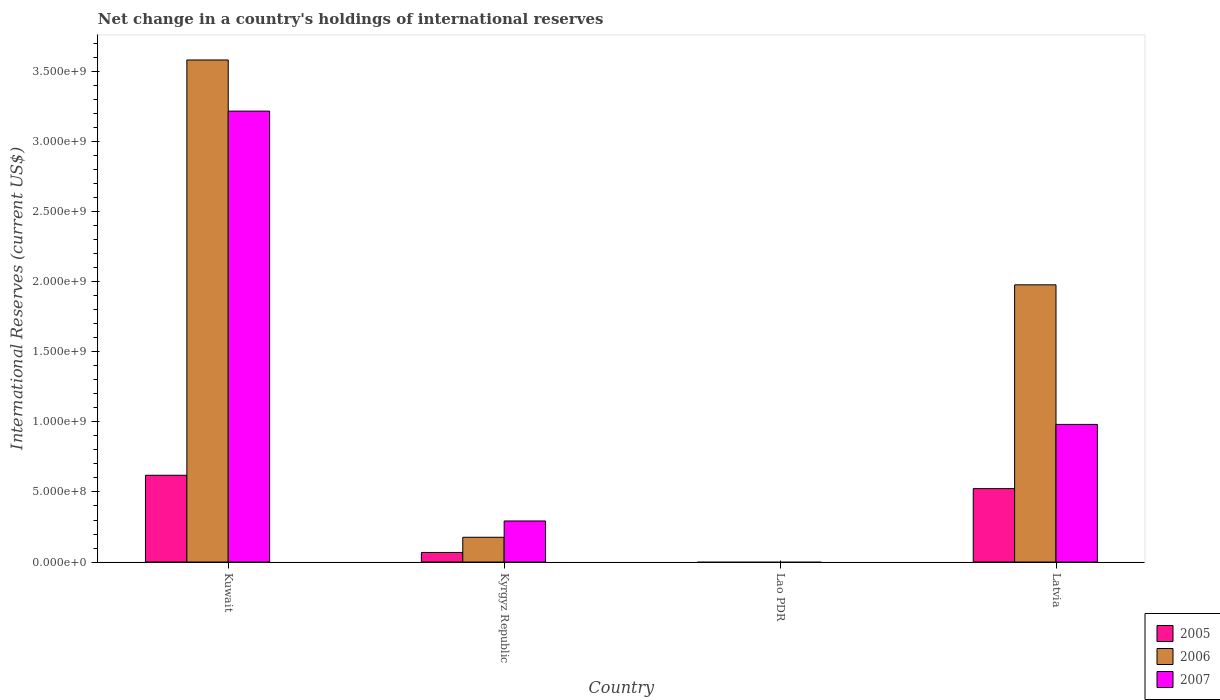How many different coloured bars are there?
Offer a terse response. 3. How many bars are there on the 1st tick from the left?
Your response must be concise. 3. How many bars are there on the 2nd tick from the right?
Your answer should be very brief. 0. What is the label of the 2nd group of bars from the left?
Provide a short and direct response. Kyrgyz Republic. What is the international reserves in 2007 in Kyrgyz Republic?
Your answer should be compact. 2.93e+08. Across all countries, what is the maximum international reserves in 2007?
Your answer should be compact. 3.22e+09. Across all countries, what is the minimum international reserves in 2006?
Provide a short and direct response. 0. In which country was the international reserves in 2006 maximum?
Offer a terse response. Kuwait. What is the total international reserves in 2007 in the graph?
Keep it short and to the point. 4.49e+09. What is the difference between the international reserves in 2007 in Kuwait and that in Kyrgyz Republic?
Provide a succinct answer. 2.93e+09. What is the difference between the international reserves in 2007 in Kyrgyz Republic and the international reserves in 2006 in Lao PDR?
Keep it short and to the point. 2.93e+08. What is the average international reserves in 2005 per country?
Your answer should be compact. 3.03e+08. What is the difference between the international reserves of/in 2006 and international reserves of/in 2007 in Kyrgyz Republic?
Give a very brief answer. -1.16e+08. What is the ratio of the international reserves in 2007 in Kuwait to that in Kyrgyz Republic?
Your answer should be very brief. 10.98. Is the international reserves in 2007 in Kuwait less than that in Latvia?
Your answer should be compact. No. What is the difference between the highest and the second highest international reserves in 2007?
Give a very brief answer. 2.24e+09. What is the difference between the highest and the lowest international reserves in 2007?
Offer a very short reply. 3.22e+09. In how many countries, is the international reserves in 2005 greater than the average international reserves in 2005 taken over all countries?
Offer a very short reply. 2. How many countries are there in the graph?
Provide a succinct answer. 4. What is the difference between two consecutive major ticks on the Y-axis?
Offer a terse response. 5.00e+08. Are the values on the major ticks of Y-axis written in scientific E-notation?
Your answer should be very brief. Yes. Does the graph contain any zero values?
Make the answer very short. Yes. Does the graph contain grids?
Your answer should be very brief. No. What is the title of the graph?
Keep it short and to the point. Net change in a country's holdings of international reserves. Does "1973" appear as one of the legend labels in the graph?
Provide a succinct answer. No. What is the label or title of the X-axis?
Provide a short and direct response. Country. What is the label or title of the Y-axis?
Offer a terse response. International Reserves (current US$). What is the International Reserves (current US$) of 2005 in Kuwait?
Ensure brevity in your answer.  6.19e+08. What is the International Reserves (current US$) of 2006 in Kuwait?
Offer a terse response. 3.58e+09. What is the International Reserves (current US$) of 2007 in Kuwait?
Offer a very short reply. 3.22e+09. What is the International Reserves (current US$) in 2005 in Kyrgyz Republic?
Give a very brief answer. 6.84e+07. What is the International Reserves (current US$) of 2006 in Kyrgyz Republic?
Keep it short and to the point. 1.77e+08. What is the International Reserves (current US$) in 2007 in Kyrgyz Republic?
Offer a terse response. 2.93e+08. What is the International Reserves (current US$) in 2007 in Lao PDR?
Your answer should be very brief. 0. What is the International Reserves (current US$) of 2005 in Latvia?
Your answer should be compact. 5.24e+08. What is the International Reserves (current US$) in 2006 in Latvia?
Ensure brevity in your answer.  1.98e+09. What is the International Reserves (current US$) of 2007 in Latvia?
Provide a succinct answer. 9.82e+08. Across all countries, what is the maximum International Reserves (current US$) in 2005?
Offer a very short reply. 6.19e+08. Across all countries, what is the maximum International Reserves (current US$) of 2006?
Ensure brevity in your answer.  3.58e+09. Across all countries, what is the maximum International Reserves (current US$) of 2007?
Offer a terse response. 3.22e+09. Across all countries, what is the minimum International Reserves (current US$) of 2005?
Make the answer very short. 0. Across all countries, what is the minimum International Reserves (current US$) in 2007?
Give a very brief answer. 0. What is the total International Reserves (current US$) of 2005 in the graph?
Keep it short and to the point. 1.21e+09. What is the total International Reserves (current US$) in 2006 in the graph?
Keep it short and to the point. 5.74e+09. What is the total International Reserves (current US$) in 2007 in the graph?
Make the answer very short. 4.49e+09. What is the difference between the International Reserves (current US$) of 2005 in Kuwait and that in Kyrgyz Republic?
Your response must be concise. 5.51e+08. What is the difference between the International Reserves (current US$) of 2006 in Kuwait and that in Kyrgyz Republic?
Offer a very short reply. 3.41e+09. What is the difference between the International Reserves (current US$) of 2007 in Kuwait and that in Kyrgyz Republic?
Provide a succinct answer. 2.93e+09. What is the difference between the International Reserves (current US$) of 2005 in Kuwait and that in Latvia?
Offer a terse response. 9.51e+07. What is the difference between the International Reserves (current US$) in 2006 in Kuwait and that in Latvia?
Offer a terse response. 1.61e+09. What is the difference between the International Reserves (current US$) of 2007 in Kuwait and that in Latvia?
Give a very brief answer. 2.24e+09. What is the difference between the International Reserves (current US$) of 2005 in Kyrgyz Republic and that in Latvia?
Ensure brevity in your answer.  -4.56e+08. What is the difference between the International Reserves (current US$) of 2006 in Kyrgyz Republic and that in Latvia?
Offer a very short reply. -1.80e+09. What is the difference between the International Reserves (current US$) in 2007 in Kyrgyz Republic and that in Latvia?
Provide a short and direct response. -6.89e+08. What is the difference between the International Reserves (current US$) of 2005 in Kuwait and the International Reserves (current US$) of 2006 in Kyrgyz Republic?
Provide a succinct answer. 4.43e+08. What is the difference between the International Reserves (current US$) of 2005 in Kuwait and the International Reserves (current US$) of 2007 in Kyrgyz Republic?
Your answer should be very brief. 3.26e+08. What is the difference between the International Reserves (current US$) of 2006 in Kuwait and the International Reserves (current US$) of 2007 in Kyrgyz Republic?
Ensure brevity in your answer.  3.29e+09. What is the difference between the International Reserves (current US$) of 2005 in Kuwait and the International Reserves (current US$) of 2006 in Latvia?
Offer a terse response. -1.36e+09. What is the difference between the International Reserves (current US$) of 2005 in Kuwait and the International Reserves (current US$) of 2007 in Latvia?
Your answer should be very brief. -3.63e+08. What is the difference between the International Reserves (current US$) of 2006 in Kuwait and the International Reserves (current US$) of 2007 in Latvia?
Ensure brevity in your answer.  2.60e+09. What is the difference between the International Reserves (current US$) in 2005 in Kyrgyz Republic and the International Reserves (current US$) in 2006 in Latvia?
Offer a terse response. -1.91e+09. What is the difference between the International Reserves (current US$) in 2005 in Kyrgyz Republic and the International Reserves (current US$) in 2007 in Latvia?
Give a very brief answer. -9.14e+08. What is the difference between the International Reserves (current US$) in 2006 in Kyrgyz Republic and the International Reserves (current US$) in 2007 in Latvia?
Your answer should be very brief. -8.06e+08. What is the average International Reserves (current US$) of 2005 per country?
Keep it short and to the point. 3.03e+08. What is the average International Reserves (current US$) in 2006 per country?
Your answer should be compact. 1.43e+09. What is the average International Reserves (current US$) of 2007 per country?
Offer a very short reply. 1.12e+09. What is the difference between the International Reserves (current US$) of 2005 and International Reserves (current US$) of 2006 in Kuwait?
Provide a short and direct response. -2.96e+09. What is the difference between the International Reserves (current US$) in 2005 and International Reserves (current US$) in 2007 in Kuwait?
Offer a very short reply. -2.60e+09. What is the difference between the International Reserves (current US$) of 2006 and International Reserves (current US$) of 2007 in Kuwait?
Keep it short and to the point. 3.65e+08. What is the difference between the International Reserves (current US$) in 2005 and International Reserves (current US$) in 2006 in Kyrgyz Republic?
Give a very brief answer. -1.08e+08. What is the difference between the International Reserves (current US$) in 2005 and International Reserves (current US$) in 2007 in Kyrgyz Republic?
Offer a terse response. -2.25e+08. What is the difference between the International Reserves (current US$) in 2006 and International Reserves (current US$) in 2007 in Kyrgyz Republic?
Your response must be concise. -1.16e+08. What is the difference between the International Reserves (current US$) of 2005 and International Reserves (current US$) of 2006 in Latvia?
Provide a short and direct response. -1.45e+09. What is the difference between the International Reserves (current US$) in 2005 and International Reserves (current US$) in 2007 in Latvia?
Give a very brief answer. -4.58e+08. What is the difference between the International Reserves (current US$) in 2006 and International Reserves (current US$) in 2007 in Latvia?
Keep it short and to the point. 9.96e+08. What is the ratio of the International Reserves (current US$) in 2005 in Kuwait to that in Kyrgyz Republic?
Your answer should be compact. 9.06. What is the ratio of the International Reserves (current US$) of 2006 in Kuwait to that in Kyrgyz Republic?
Ensure brevity in your answer.  20.28. What is the ratio of the International Reserves (current US$) in 2007 in Kuwait to that in Kyrgyz Republic?
Make the answer very short. 10.98. What is the ratio of the International Reserves (current US$) in 2005 in Kuwait to that in Latvia?
Make the answer very short. 1.18. What is the ratio of the International Reserves (current US$) of 2006 in Kuwait to that in Latvia?
Provide a short and direct response. 1.81. What is the ratio of the International Reserves (current US$) of 2007 in Kuwait to that in Latvia?
Your answer should be compact. 3.28. What is the ratio of the International Reserves (current US$) in 2005 in Kyrgyz Republic to that in Latvia?
Offer a very short reply. 0.13. What is the ratio of the International Reserves (current US$) in 2006 in Kyrgyz Republic to that in Latvia?
Your response must be concise. 0.09. What is the ratio of the International Reserves (current US$) of 2007 in Kyrgyz Republic to that in Latvia?
Your response must be concise. 0.3. What is the difference between the highest and the second highest International Reserves (current US$) in 2005?
Make the answer very short. 9.51e+07. What is the difference between the highest and the second highest International Reserves (current US$) of 2006?
Keep it short and to the point. 1.61e+09. What is the difference between the highest and the second highest International Reserves (current US$) of 2007?
Your answer should be very brief. 2.24e+09. What is the difference between the highest and the lowest International Reserves (current US$) in 2005?
Your answer should be compact. 6.19e+08. What is the difference between the highest and the lowest International Reserves (current US$) of 2006?
Offer a terse response. 3.58e+09. What is the difference between the highest and the lowest International Reserves (current US$) of 2007?
Your answer should be very brief. 3.22e+09. 